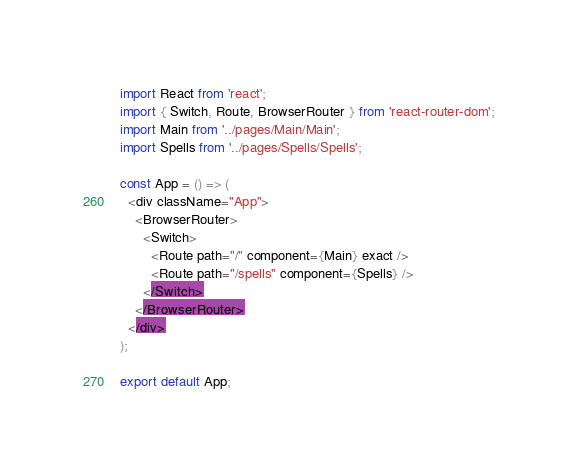<code> <loc_0><loc_0><loc_500><loc_500><_TypeScript_>import React from 'react';
import { Switch, Route, BrowserRouter } from 'react-router-dom';
import Main from '../pages/Main/Main';
import Spells from '../pages/Spells/Spells';

const App = () => (
  <div className="App">
    <BrowserRouter>
      <Switch>
        <Route path="/" component={Main} exact />
        <Route path="/spells" component={Spells} />
      </Switch>
    </BrowserRouter>
  </div>
);

export default App;
</code> 